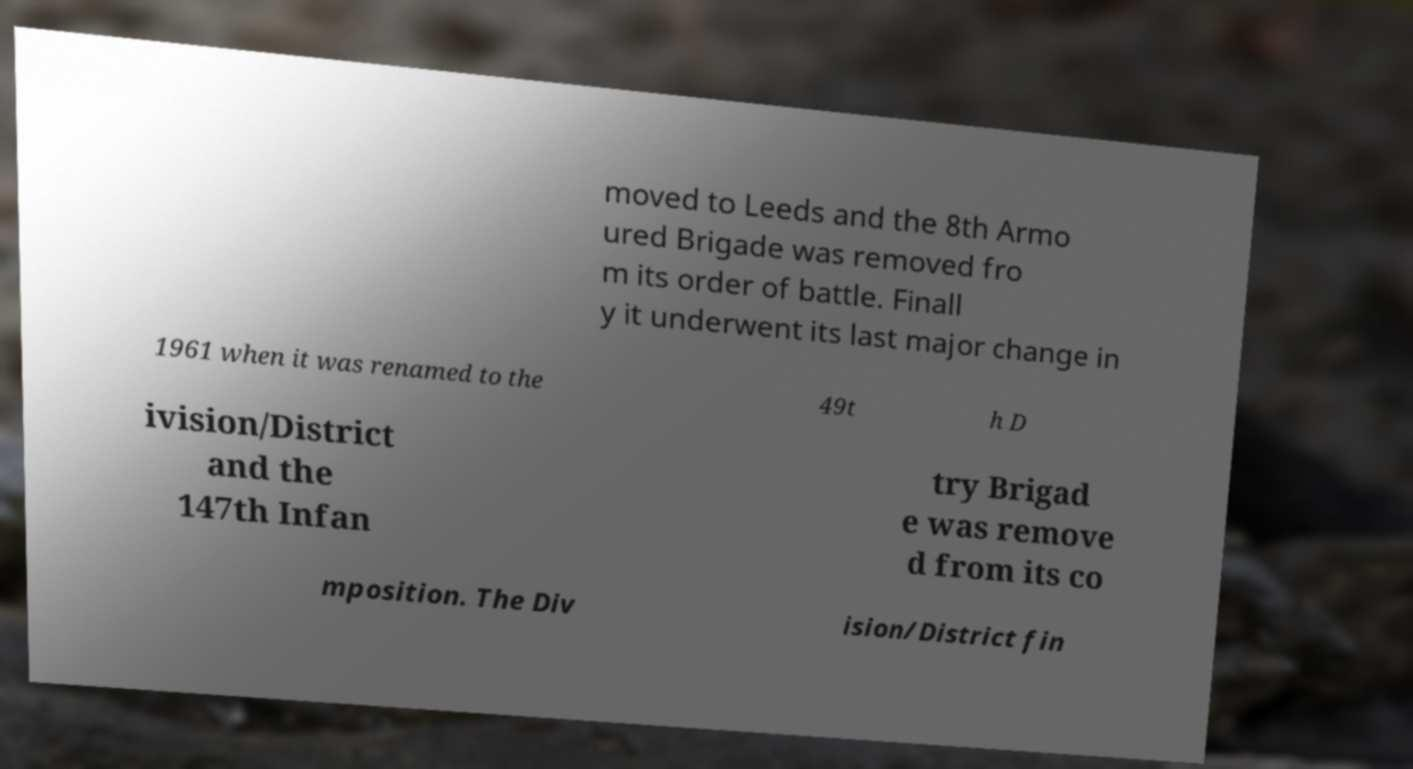Can you accurately transcribe the text from the provided image for me? moved to Leeds and the 8th Armo ured Brigade was removed fro m its order of battle. Finall y it underwent its last major change in 1961 when it was renamed to the 49t h D ivision/District and the 147th Infan try Brigad e was remove d from its co mposition. The Div ision/District fin 